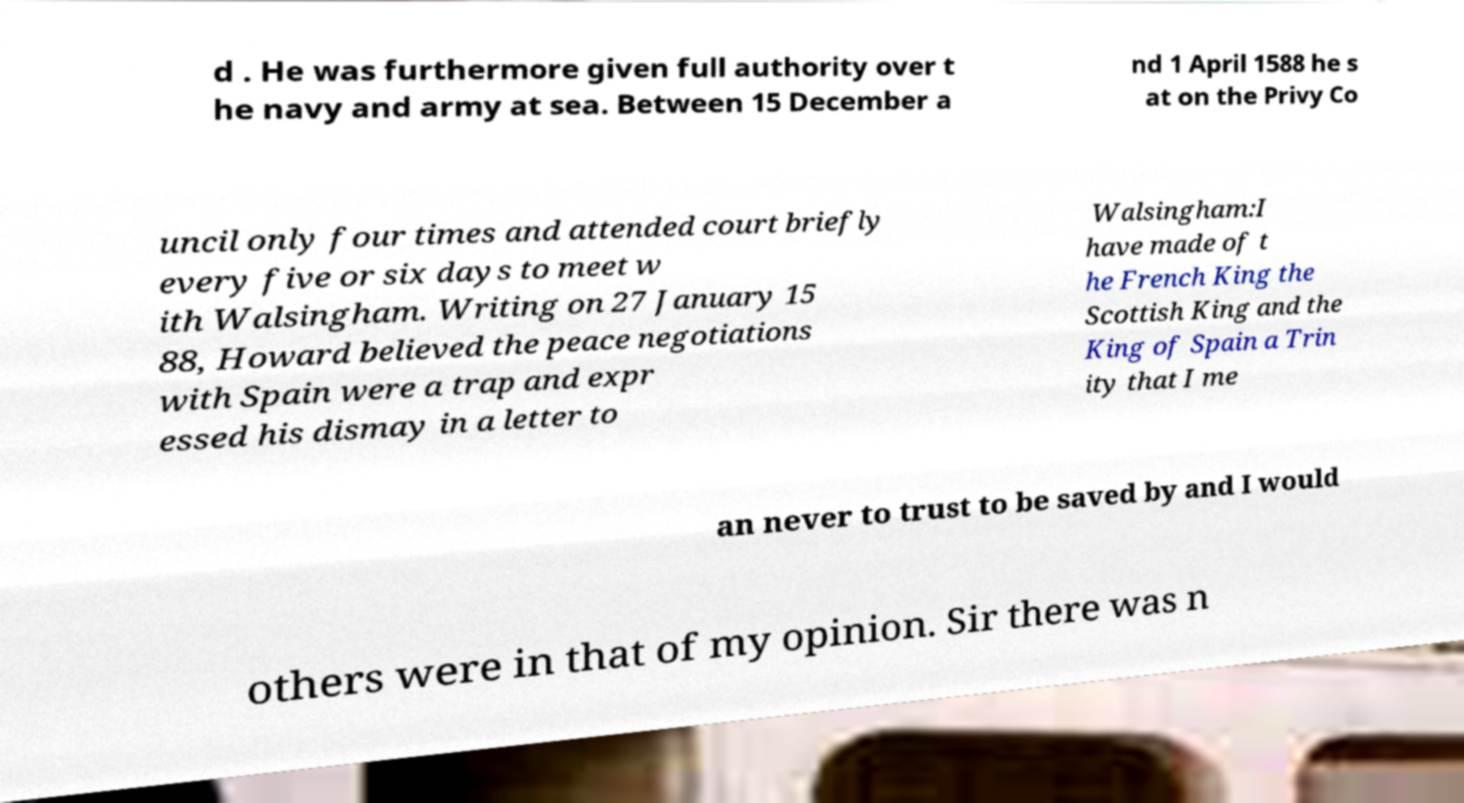Could you extract and type out the text from this image? d . He was furthermore given full authority over t he navy and army at sea. Between 15 December a nd 1 April 1588 he s at on the Privy Co uncil only four times and attended court briefly every five or six days to meet w ith Walsingham. Writing on 27 January 15 88, Howard believed the peace negotiations with Spain were a trap and expr essed his dismay in a letter to Walsingham:I have made of t he French King the Scottish King and the King of Spain a Trin ity that I me an never to trust to be saved by and I would others were in that of my opinion. Sir there was n 